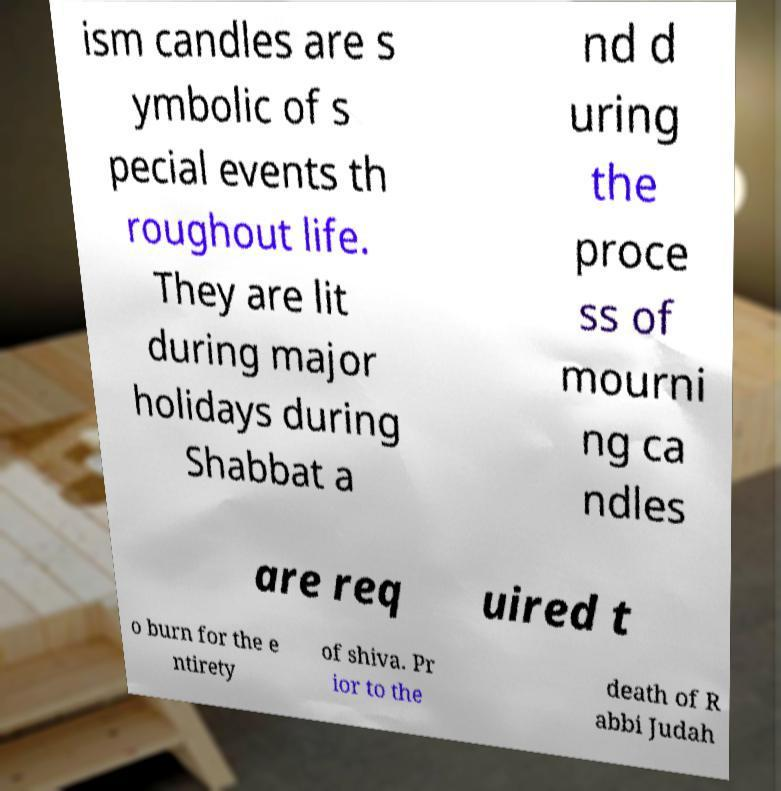What messages or text are displayed in this image? I need them in a readable, typed format. ism candles are s ymbolic of s pecial events th roughout life. They are lit during major holidays during Shabbat a nd d uring the proce ss of mourni ng ca ndles are req uired t o burn for the e ntirety of shiva. Pr ior to the death of R abbi Judah 